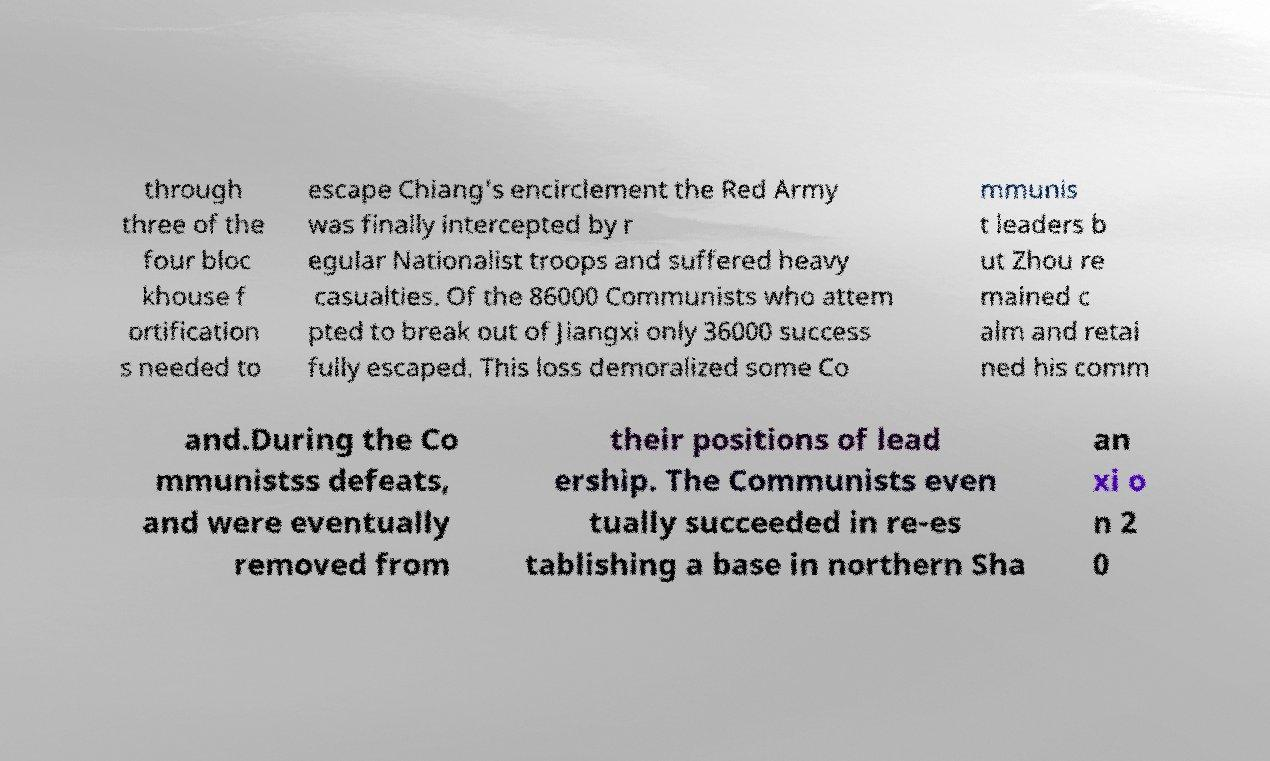Can you read and provide the text displayed in the image?This photo seems to have some interesting text. Can you extract and type it out for me? through three of the four bloc khouse f ortification s needed to escape Chiang's encirclement the Red Army was finally intercepted by r egular Nationalist troops and suffered heavy casualties. Of the 86000 Communists who attem pted to break out of Jiangxi only 36000 success fully escaped. This loss demoralized some Co mmunis t leaders b ut Zhou re mained c alm and retai ned his comm and.During the Co mmunistss defeats, and were eventually removed from their positions of lead ership. The Communists even tually succeeded in re-es tablishing a base in northern Sha an xi o n 2 0 